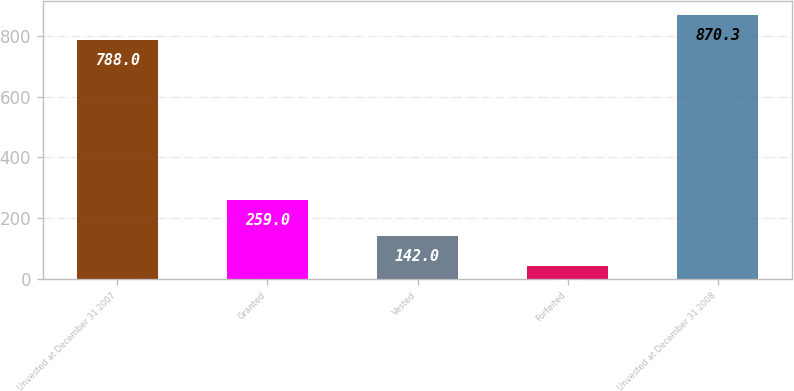Convert chart to OTSL. <chart><loc_0><loc_0><loc_500><loc_500><bar_chart><fcel>Unvested at December 31 2007<fcel>Granted<fcel>Vested<fcel>Forfeited<fcel>Unvested at December 31 2008<nl><fcel>788<fcel>259<fcel>142<fcel>41<fcel>870.3<nl></chart> 